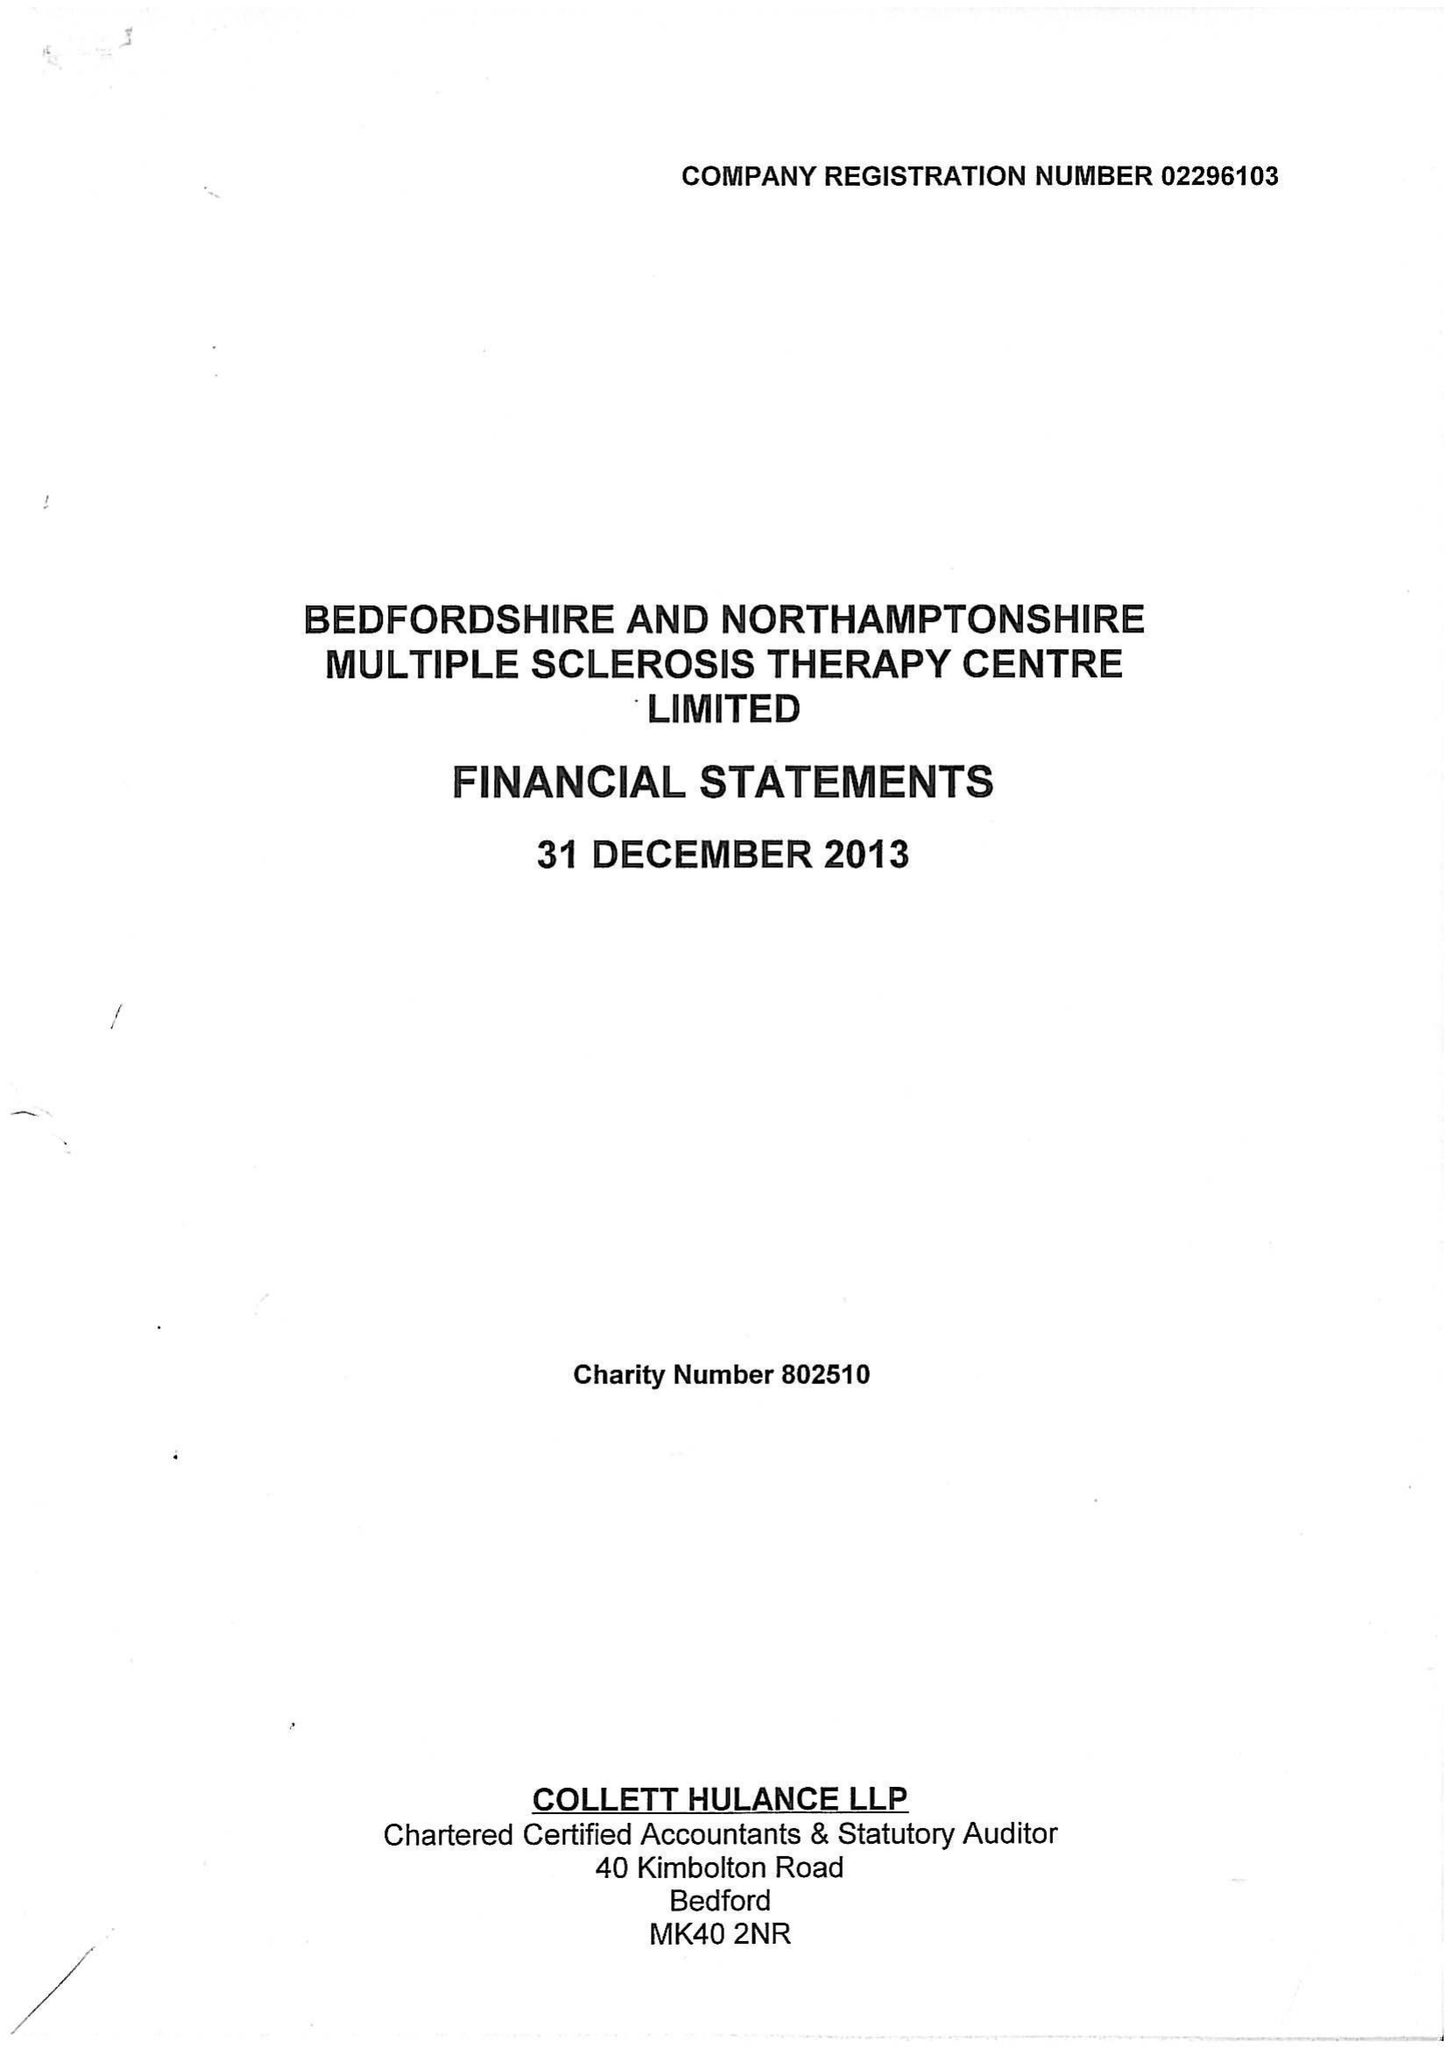What is the value for the charity_name?
Answer the question using a single word or phrase. Bedfordshire and Northamptonshire Multiple Sclerosis Therapy Centre Ltd. 